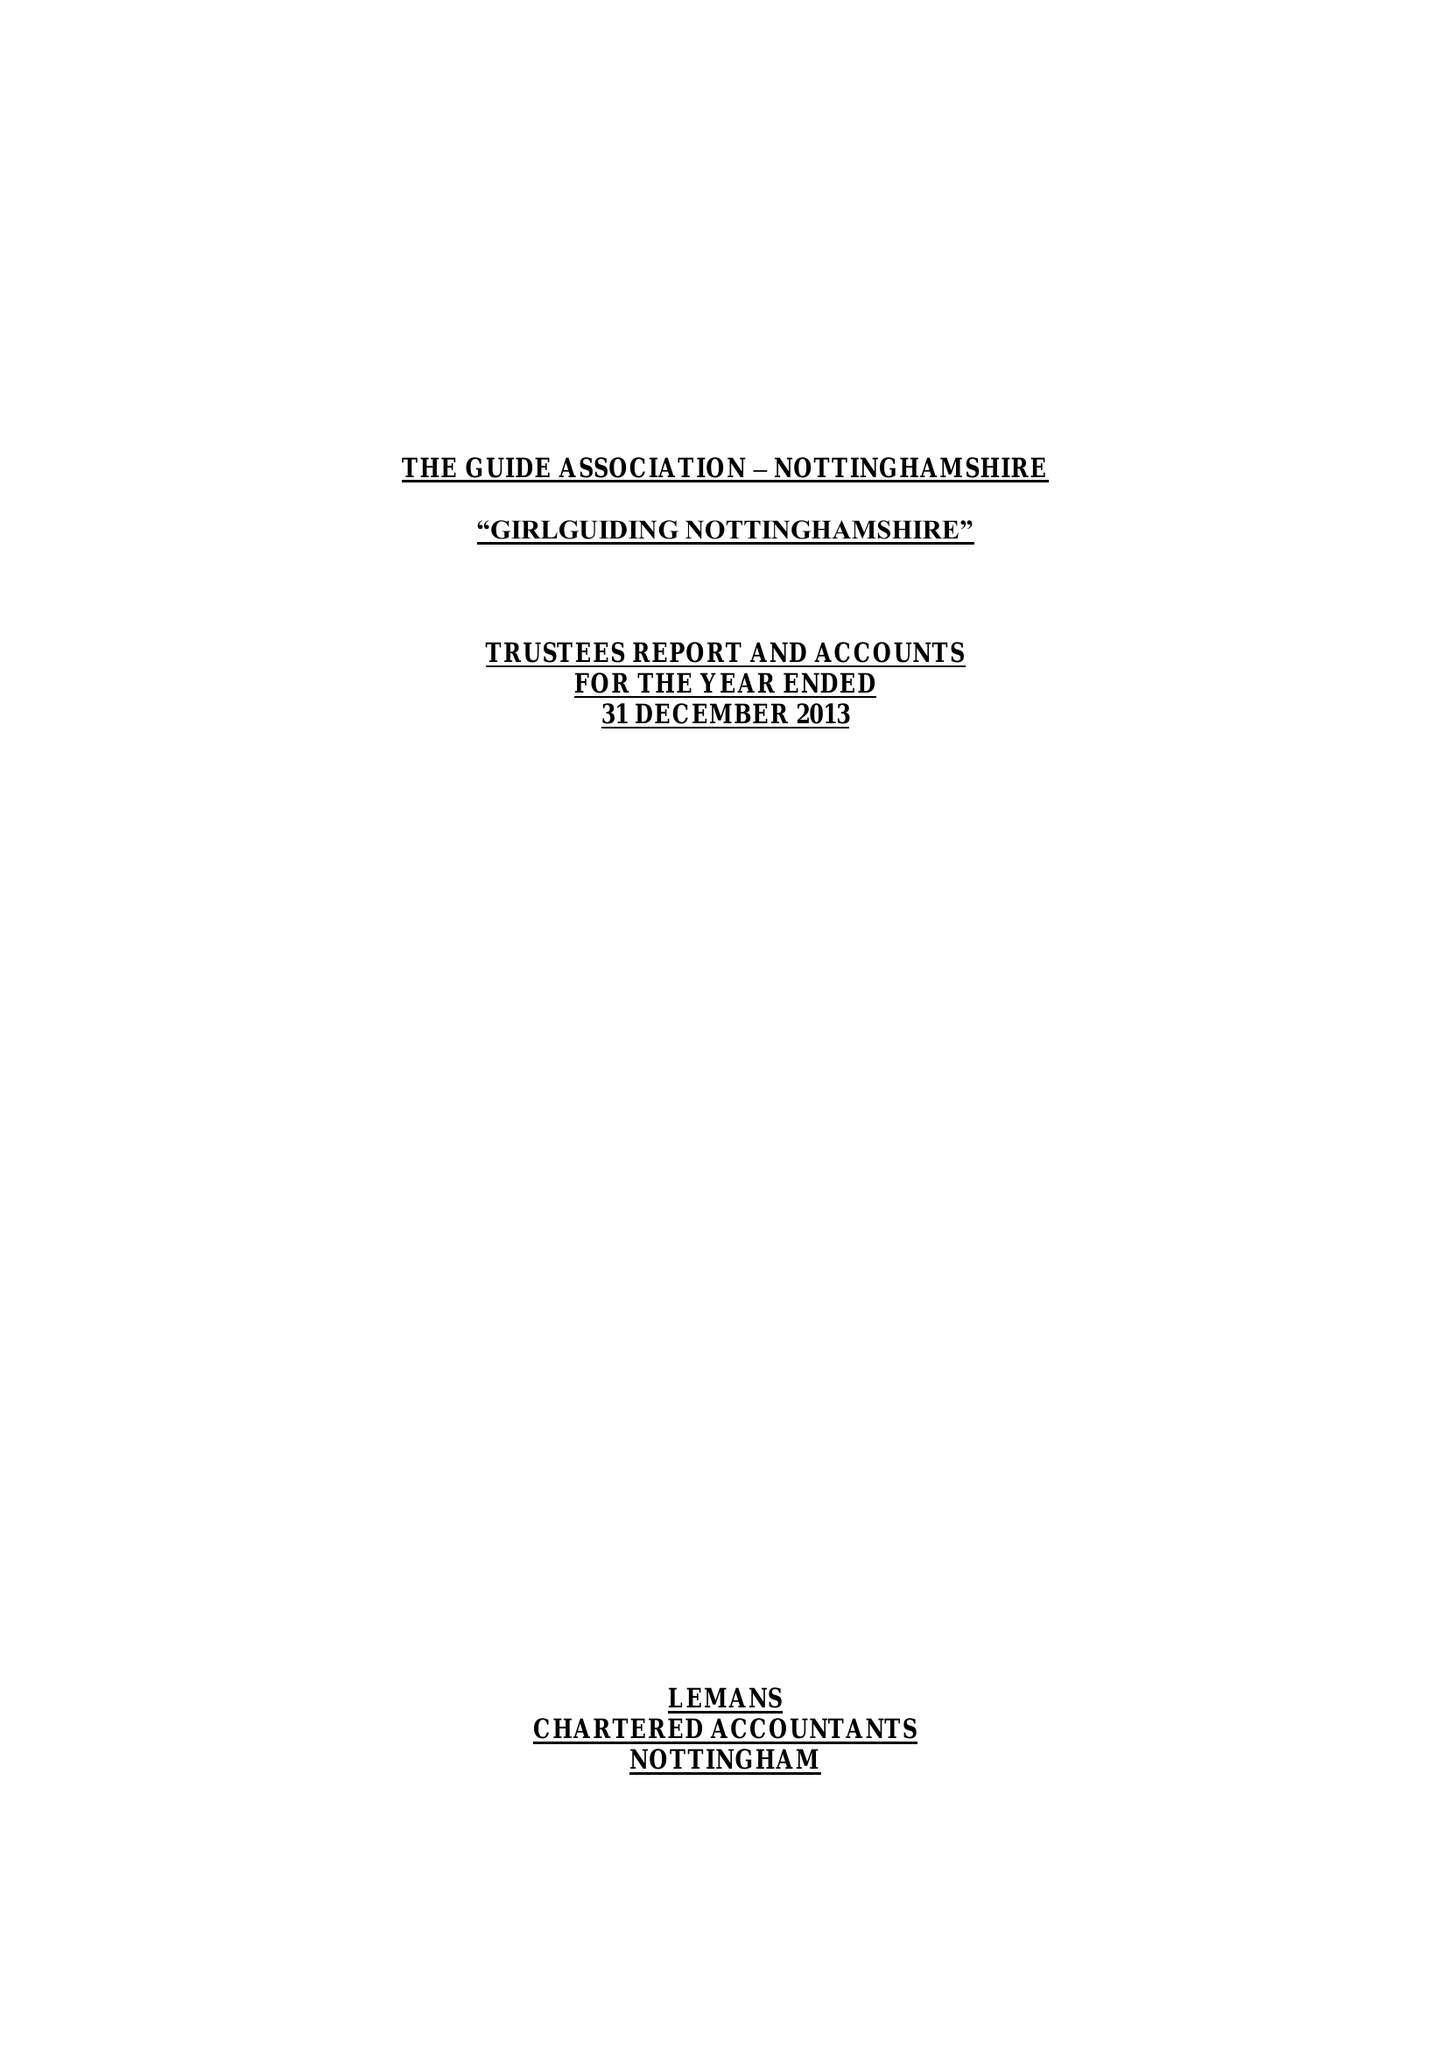What is the value for the address__street_line?
Answer the question using a single word or phrase. 16-18 BURTON ROAD 